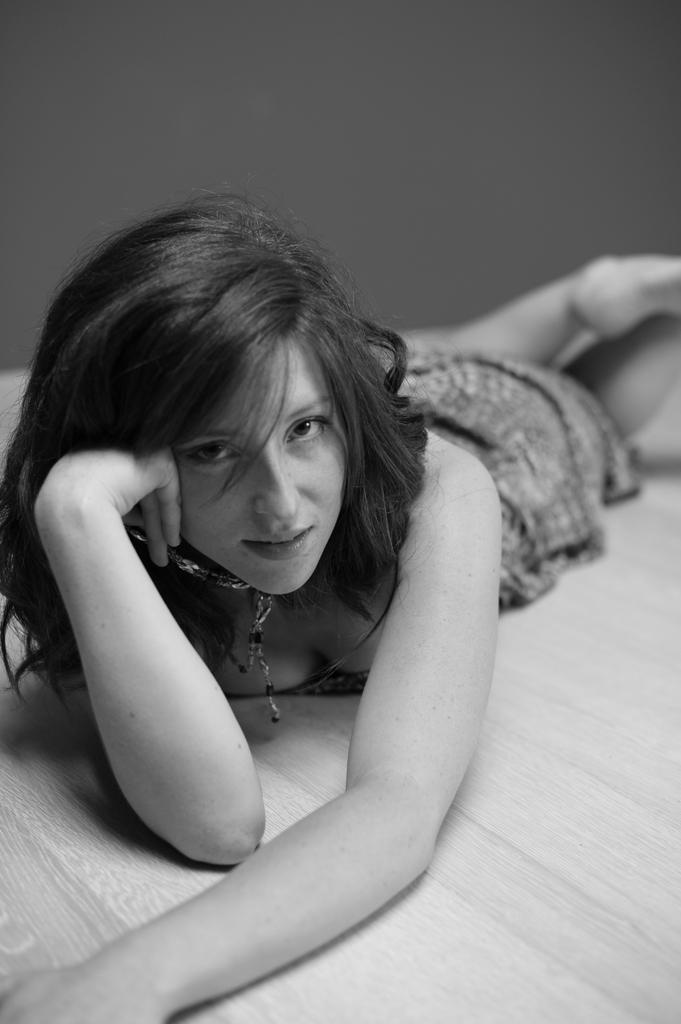What is the color scheme of the image? The image is black and white. Who is present in the image? There is a lady in the image. What is the lady doing in the image? The lady is lying on a surface. What is the price of the vessel in the image? There is no vessel present in the image, so it is not possible to determine its price. 